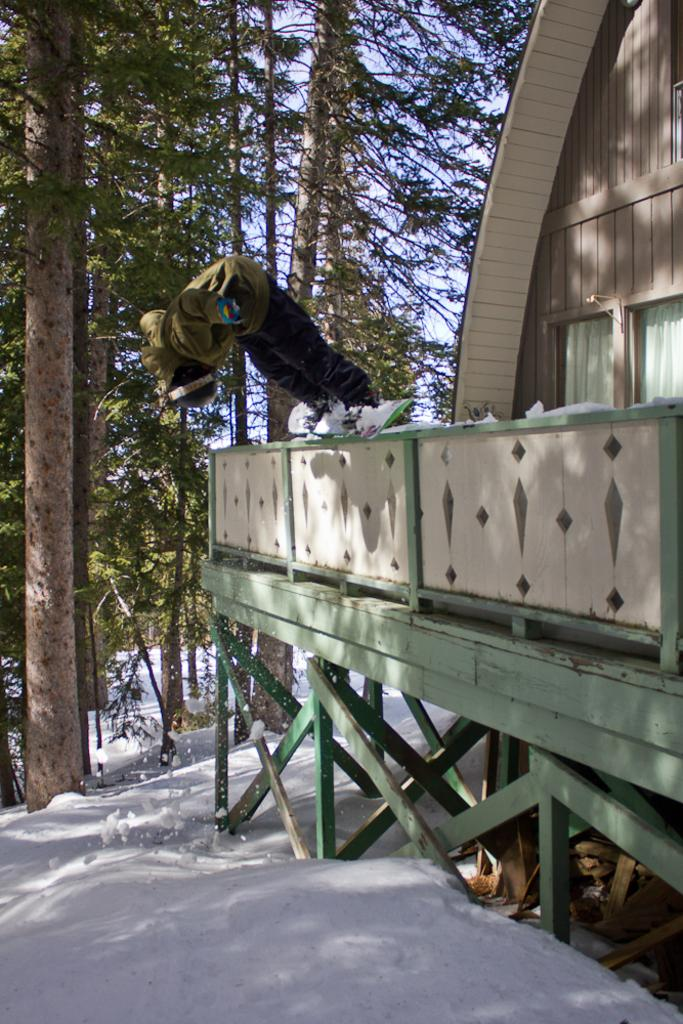What type of house is in the image? There is a wooden house in the image. What is located near the house? There is a fence in the image. What else can be seen in the image besides the house and fence? There are other objects in the image. What is the weather like in the image? There is snow visible in the background of the image, suggesting a cold or wintery setting. What else can be seen in the background of the image? There are trees and the sky visible in the background of the image. What type of beetle can be seen crawling on the frame of the wooden house in the image? There is no beetle present on the frame of the wooden house in the image. What is the front of the wooden house made of in the image? The provided facts do not mention the material of the front of the wooden house, only that it is a wooden house. 